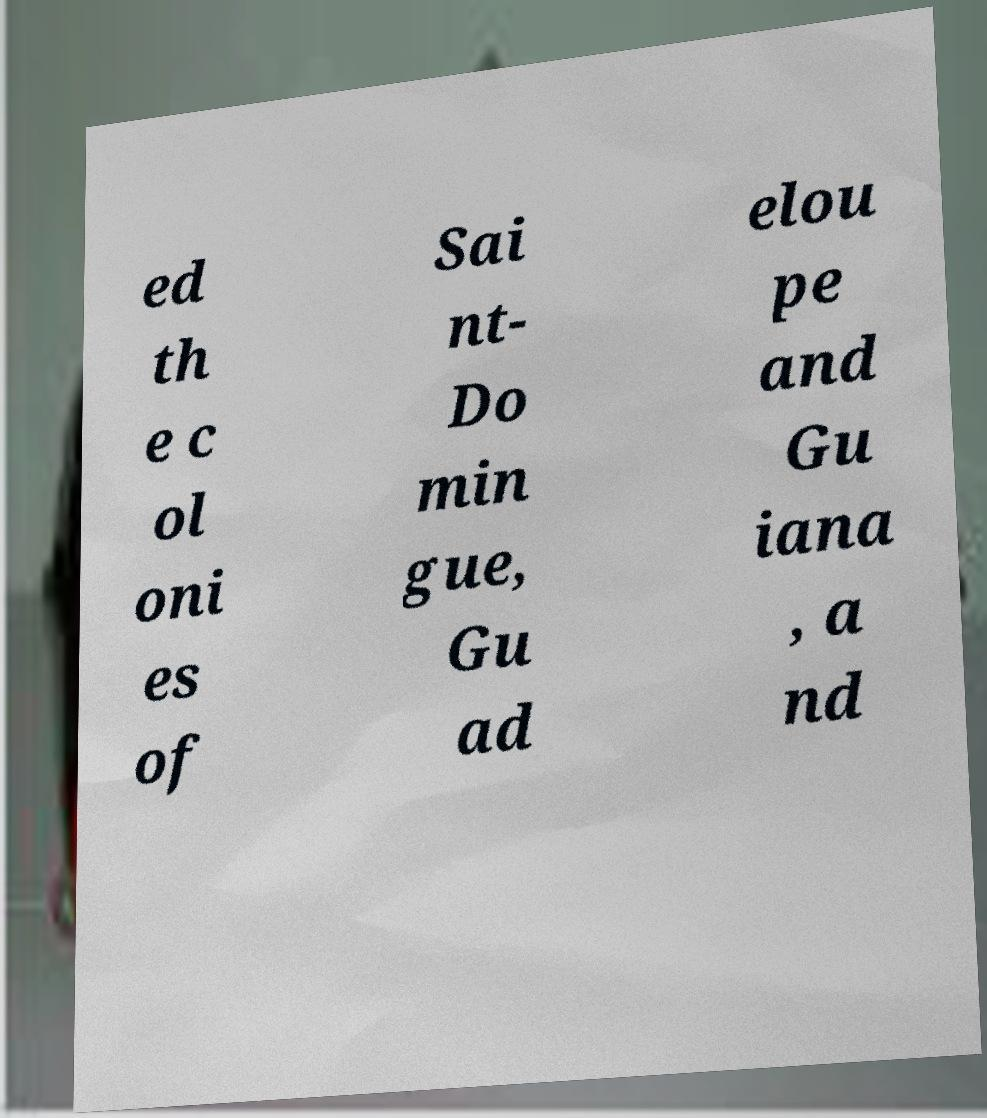Can you read and provide the text displayed in the image?This photo seems to have some interesting text. Can you extract and type it out for me? ed th e c ol oni es of Sai nt- Do min gue, Gu ad elou pe and Gu iana , a nd 